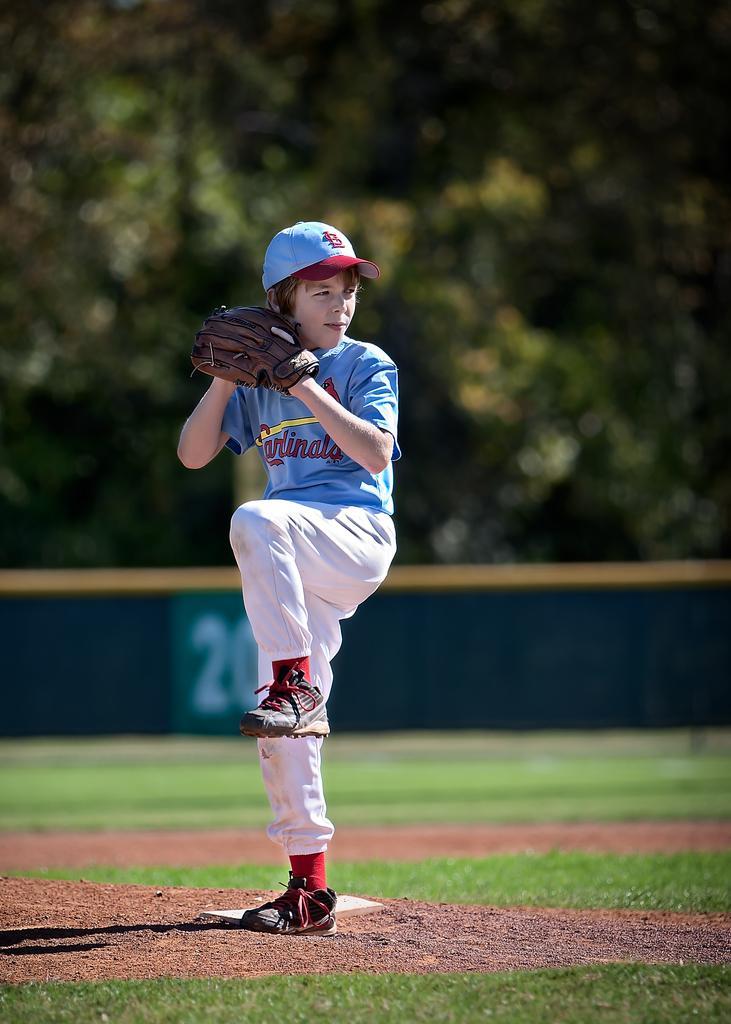In one or two sentences, can you explain what this image depicts? In this image we can see a boy playing baseball, there are trees behind him, and the background is blurred. 